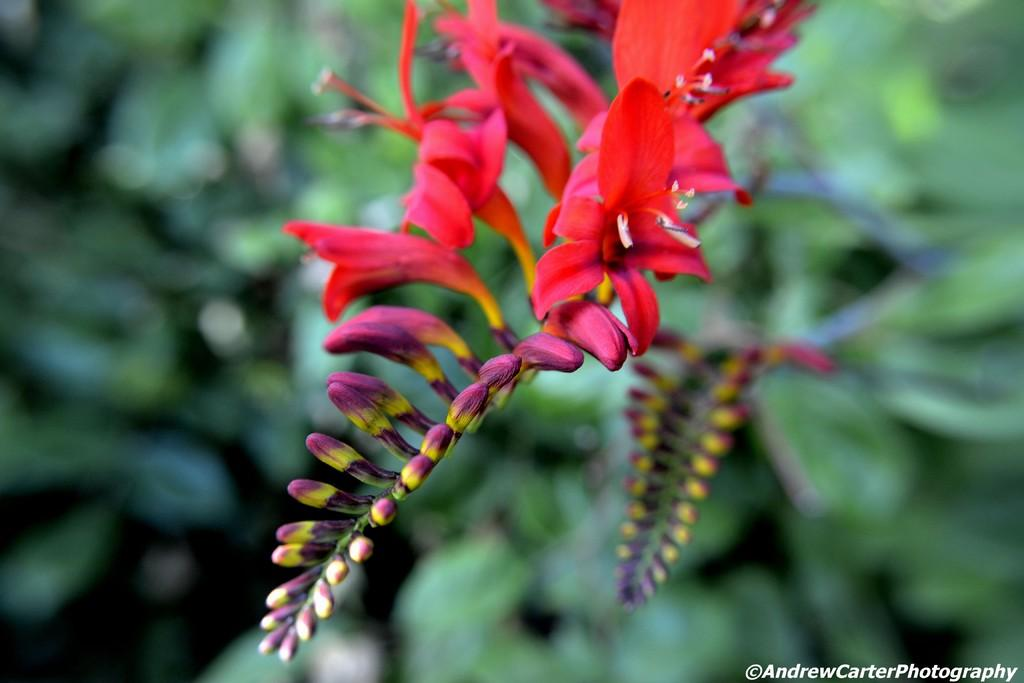What type of plants are present in the image? There are red color flowering plants in the image. How many cards are visible on the table in the image? There are no cards present in the image; it only features red color flowering plants. What type of nerve is responsible for the movement of the plants in the image? There is no movement of the plants in the image, and plants do not have nerves like animals. 